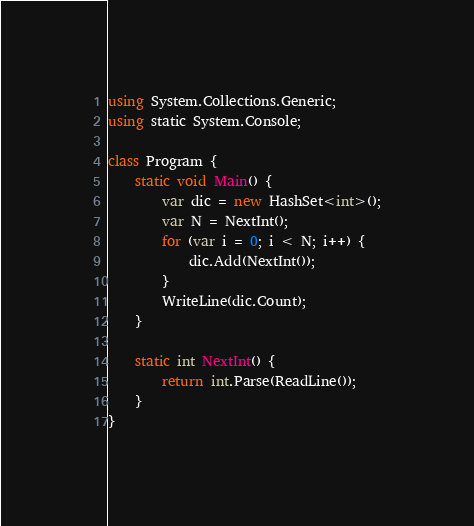Convert code to text. <code><loc_0><loc_0><loc_500><loc_500><_C#_>using System.Collections.Generic;
using static System.Console;

class Program {
	static void Main() {
		var dic = new HashSet<int>();
		var N = NextInt();
		for (var i = 0; i < N; i++) {
			dic.Add(NextInt());
		}
		WriteLine(dic.Count);
	}

	static int NextInt() {
		return int.Parse(ReadLine());
	}
}</code> 